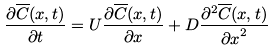<formula> <loc_0><loc_0><loc_500><loc_500>\frac { \partial { \overline { C } ( x , t ) } } { \partial t } = U \frac { \partial { \overline { C } ( x , t ) } } { \partial x } + D \frac { \partial ^ { 2 } { \overline { C } ( x , t ) } } { { \partial x } ^ { 2 } }</formula> 